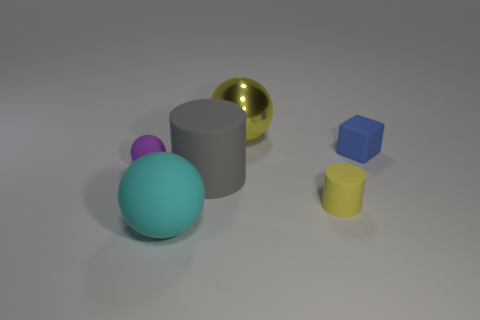Are there fewer yellow matte spheres than big yellow objects?
Offer a very short reply. Yes. How many objects are tiny matte spheres or yellow rubber cylinders?
Offer a very short reply. 2. Do the tiny blue object and the big gray object have the same shape?
Give a very brief answer. No. Are there any other things that are made of the same material as the yellow sphere?
Your answer should be compact. No. There is a yellow object on the right side of the big yellow metal object; does it have the same size as the thing left of the large cyan rubber sphere?
Offer a very short reply. Yes. There is a ball that is left of the shiny thing and right of the small matte sphere; what is its material?
Your answer should be compact. Rubber. Is there anything else of the same color as the large rubber cylinder?
Offer a very short reply. No. Is the number of purple matte spheres in front of the small purple thing less than the number of big yellow things?
Give a very brief answer. Yes. Are there more small yellow things than things?
Your answer should be compact. No. There is a large rubber object behind the yellow object that is in front of the tiny rubber block; are there any large gray matte things behind it?
Offer a terse response. No. 